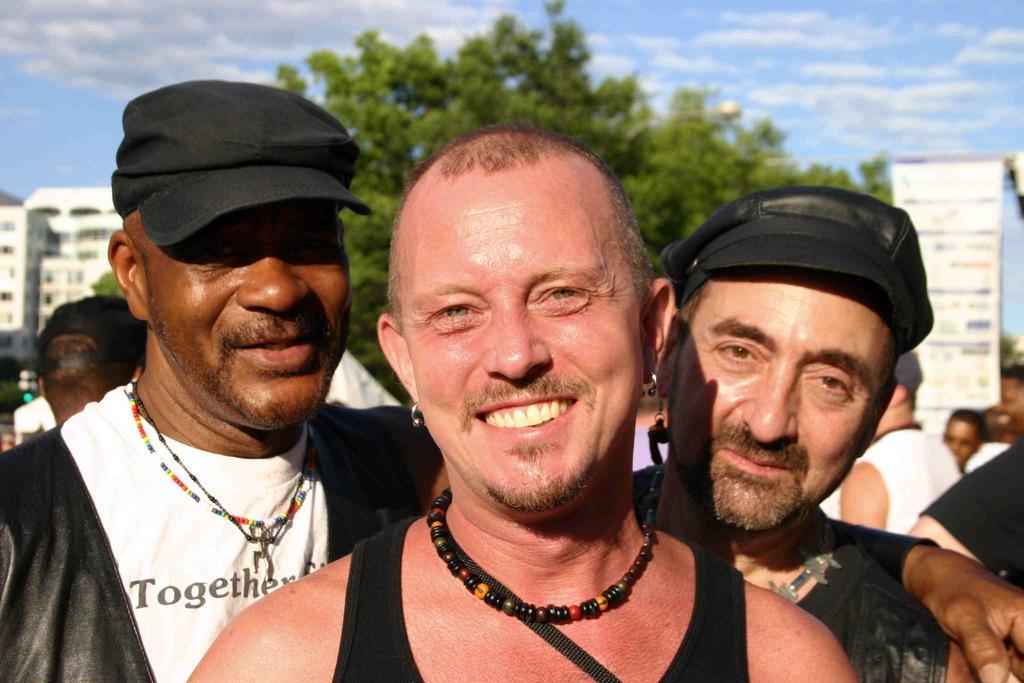Could you give a brief overview of what you see in this image? In this image I can see three men are standing in the front. I can also see two of them are wearing caps and on their faces I can see smile. In the background I can see a building, a tree, few more people, clouds, the sky and a white colour board. 